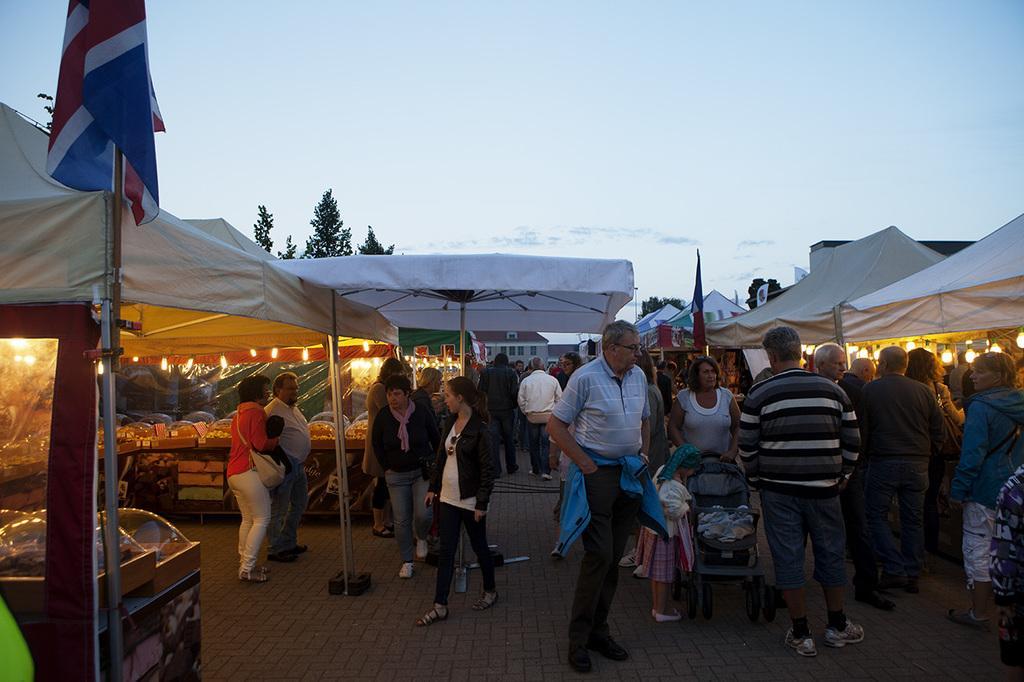Describe this image in one or two sentences. This picture might be taken in a market, in this picture there are some people who are walking and some of them are standing near the stores. On the right side and left side there are some stores, in the background there are some trees and houses and also we could see some poles and flags. 